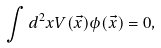Convert formula to latex. <formula><loc_0><loc_0><loc_500><loc_500>\int d ^ { 2 } x V ( \vec { x } ) \phi ( \vec { x } ) = 0 ,</formula> 